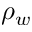Convert formula to latex. <formula><loc_0><loc_0><loc_500><loc_500>\rho _ { w }</formula> 